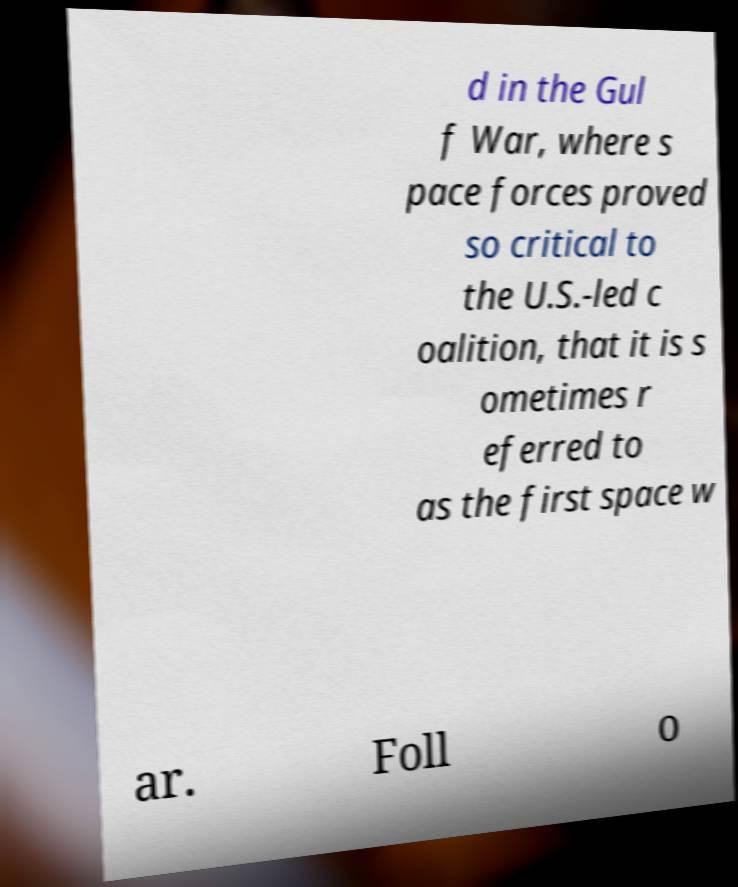Could you assist in decoding the text presented in this image and type it out clearly? d in the Gul f War, where s pace forces proved so critical to the U.S.-led c oalition, that it is s ometimes r eferred to as the first space w ar. Foll o 